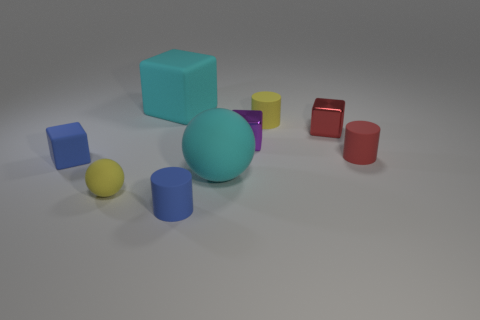Add 1 tiny rubber cylinders. How many objects exist? 10 Subtract all cylinders. How many objects are left? 6 Add 1 small yellow objects. How many small yellow objects exist? 3 Subtract 1 red blocks. How many objects are left? 8 Subtract all yellow rubber things. Subtract all purple cubes. How many objects are left? 6 Add 5 shiny things. How many shiny things are left? 7 